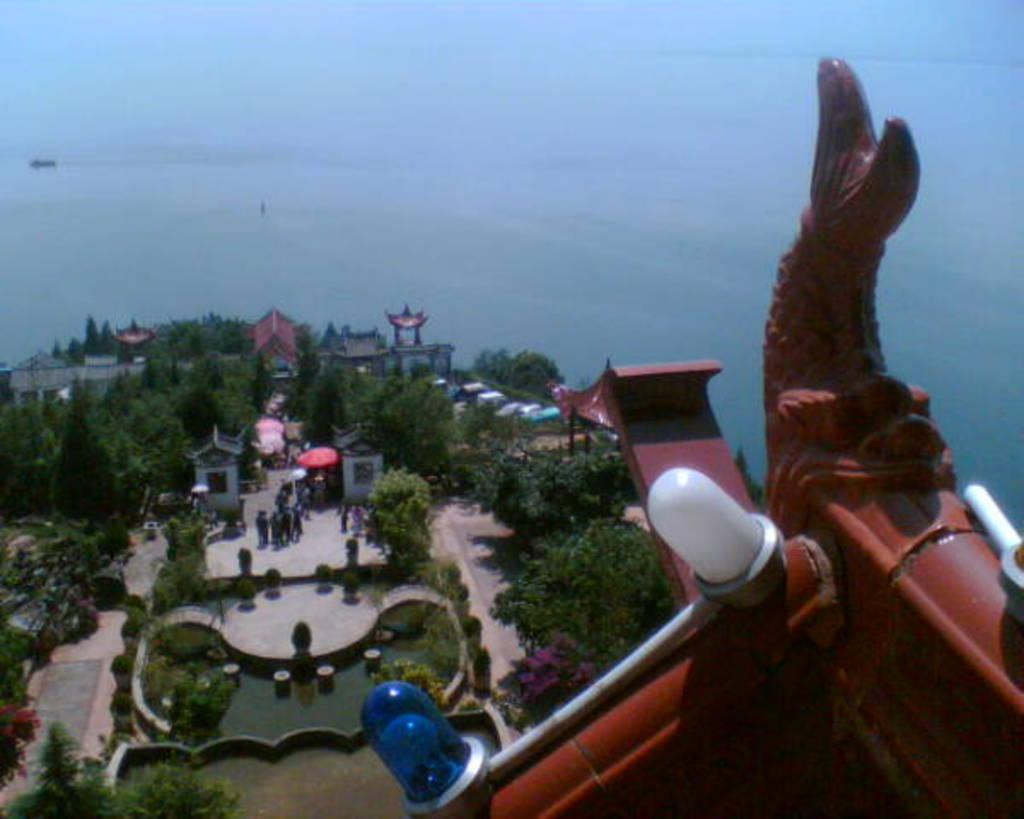What type of natural elements can be seen in the image? There are trees in the image. What type of man-made structures are present in the image? There are buildings in the image. What are the people in the image doing? The people are standing on the ground in the image. What is the red object with lights in the image? The red object with lights could be a traffic signal or a similar object. What is visible in the background of the image? The sky is visible in the background of the image. What type of silver material can be seen on the person in the image? There is no silver material or person mentioned in the image; it features trees, buildings, people, and a red object with lights. How many copper coins are scattered on the ground in the image? There is no mention of copper coins in the image; it only mentions people standing on the ground. 